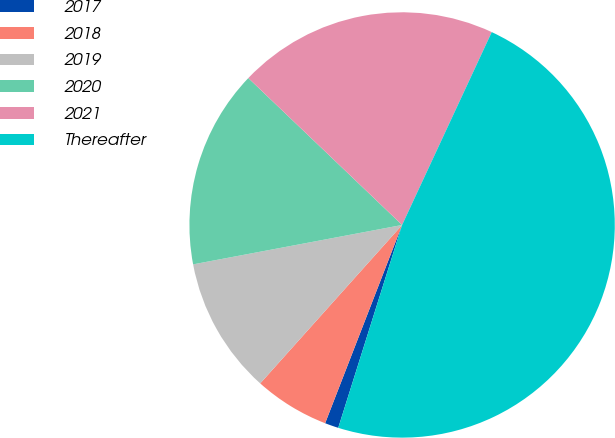Convert chart to OTSL. <chart><loc_0><loc_0><loc_500><loc_500><pie_chart><fcel>2017<fcel>2018<fcel>2019<fcel>2020<fcel>2021<fcel>Thereafter<nl><fcel>1.04%<fcel>5.73%<fcel>10.41%<fcel>15.1%<fcel>19.79%<fcel>47.93%<nl></chart> 